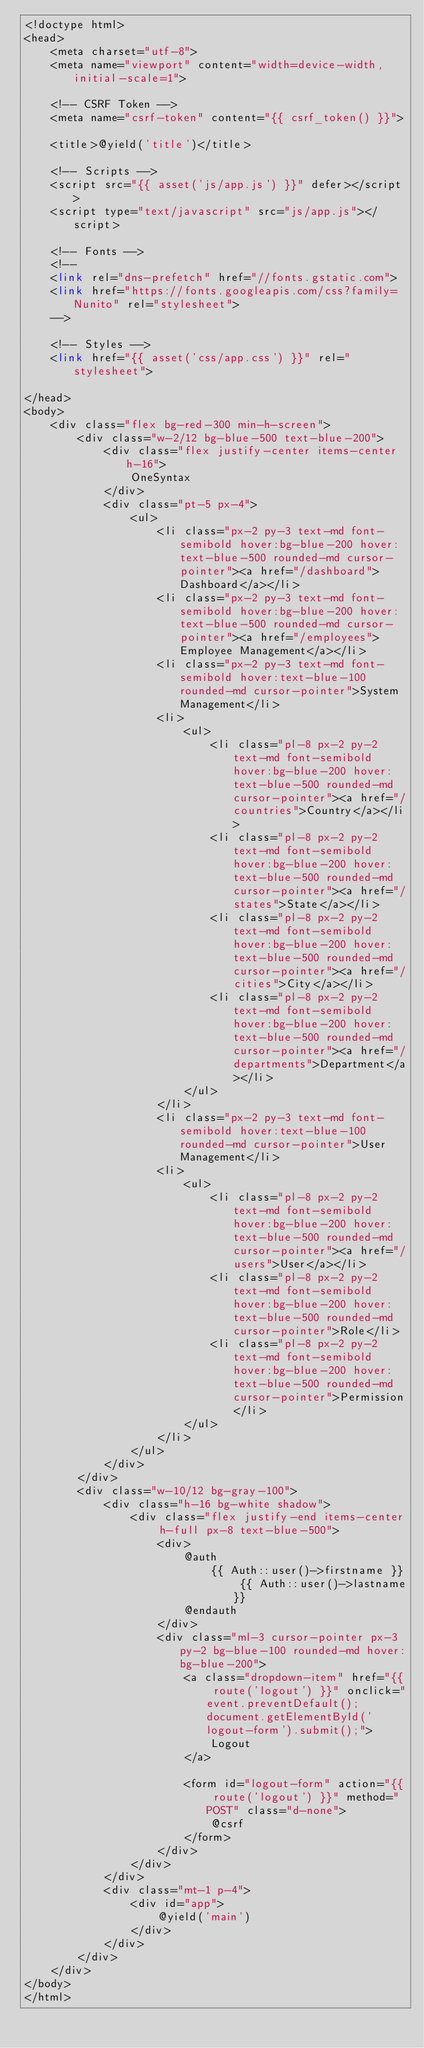<code> <loc_0><loc_0><loc_500><loc_500><_PHP_><!doctype html>
<head>
    <meta charset="utf-8">
    <meta name="viewport" content="width=device-width, initial-scale=1">

    <!-- CSRF Token -->
    <meta name="csrf-token" content="{{ csrf_token() }}">

    <title>@yield('title')</title>

    <!-- Scripts -->
    <script src="{{ asset('js/app.js') }}" defer></script>
    <script type="text/javascript" src="js/app.js"></script>

    <!-- Fonts -->
    <!--
    <link rel="dns-prefetch" href="//fonts.gstatic.com">
    <link href="https://fonts.googleapis.com/css?family=Nunito" rel="stylesheet">
    -->

    <!-- Styles -->
    <link href="{{ asset('css/app.css') }}" rel="stylesheet">

</head>
<body>
    <div class="flex bg-red-300 min-h-screen">
        <div class="w-2/12 bg-blue-500 text-blue-200">
            <div class="flex justify-center items-center h-16">
                OneSyntax
            </div>
            <div class="pt-5 px-4">
                <ul>
                    <li class="px-2 py-3 text-md font-semibold hover:bg-blue-200 hover:text-blue-500 rounded-md cursor-pointer"><a href="/dashboard">Dashboard</a></li>
                    <li class="px-2 py-3 text-md font-semibold hover:bg-blue-200 hover:text-blue-500 rounded-md cursor-pointer"><a href="/employees">Employee Management</a></li>
                    <li class="px-2 py-3 text-md font-semibold hover:text-blue-100 rounded-md cursor-pointer">System Management</li>
                    <li>
                        <ul>
                            <li class="pl-8 px-2 py-2 text-md font-semibold hover:bg-blue-200 hover:text-blue-500 rounded-md cursor-pointer"><a href="/countries">Country</a></li>
                            <li class="pl-8 px-2 py-2 text-md font-semibold hover:bg-blue-200 hover:text-blue-500 rounded-md cursor-pointer"><a href="/states">State</a></li>
                            <li class="pl-8 px-2 py-2 text-md font-semibold hover:bg-blue-200 hover:text-blue-500 rounded-md cursor-pointer"><a href="/cities">City</a></li>
                            <li class="pl-8 px-2 py-2 text-md font-semibold hover:bg-blue-200 hover:text-blue-500 rounded-md cursor-pointer"><a href="/departments">Department</a></li>
                        </ul>
                    </li>
                    <li class="px-2 py-3 text-md font-semibold hover:text-blue-100 rounded-md cursor-pointer">User Management</li>
                    <li>
                        <ul>
                            <li class="pl-8 px-2 py-2 text-md font-semibold hover:bg-blue-200 hover:text-blue-500 rounded-md cursor-pointer"><a href="/users">User</a></li>
                            <li class="pl-8 px-2 py-2 text-md font-semibold hover:bg-blue-200 hover:text-blue-500 rounded-md cursor-pointer">Role</li>
                            <li class="pl-8 px-2 py-2 text-md font-semibold hover:bg-blue-200 hover:text-blue-500 rounded-md cursor-pointer">Permission</li>
                        </ul>
                    </li>
                </ul>
            </div>
        </div>
        <div class="w-10/12 bg-gray-100">
            <div class="h-16 bg-white shadow">
                <div class="flex justify-end items-center h-full px-8 text-blue-500">
                    <div>
                        @auth
                            {{ Auth::user()->firstname }} {{ Auth::user()->lastname}}
                        @endauth
                    </div>
                    <div class="ml-3 cursor-pointer px-3 py-2 bg-blue-100 rounded-md hover:bg-blue-200">
                        <a class="dropdown-item" href="{{ route('logout') }}" onclick="event.preventDefault(); document.getElementById('logout-form').submit();">
                            Logout
                        </a>

                        <form id="logout-form" action="{{ route('logout') }}" method="POST" class="d-none">
                            @csrf
                        </form>
                    </div>
                </div>
            </div>
            <div class="mt-1 p-4">
                <div id="app">
                    @yield('main')
                </div>
            </div>
        </div>
    </div>
</body>
</html>
</code> 